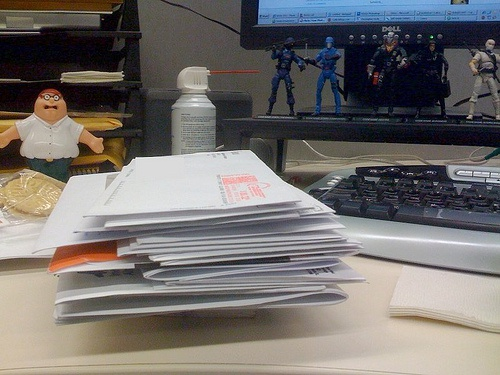Describe the objects in this image and their specific colors. I can see keyboard in maroon, darkgray, black, and gray tones, tv in maroon, black, darkgray, and gray tones, bottle in maroon, darkgray, gray, and lightgray tones, book in maroon, black, darkgreen, and gray tones, and book in maroon, gray, and tan tones in this image. 